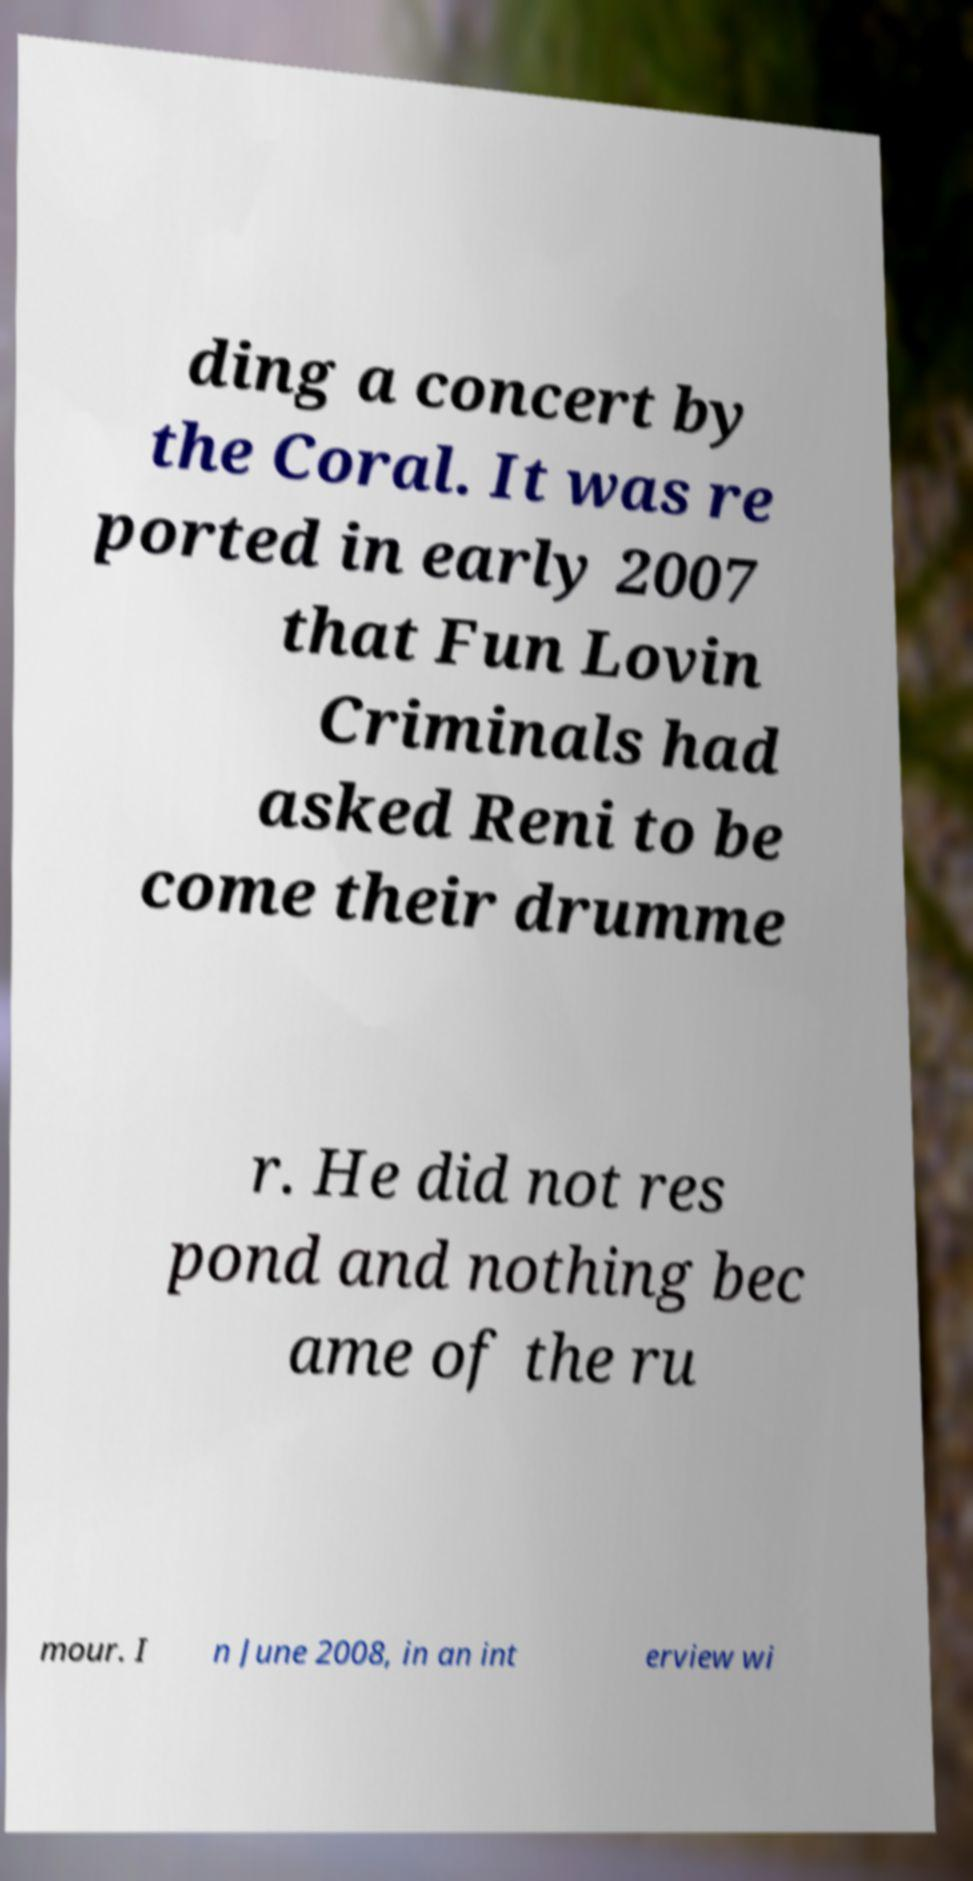Please identify and transcribe the text found in this image. ding a concert by the Coral. It was re ported in early 2007 that Fun Lovin Criminals had asked Reni to be come their drumme r. He did not res pond and nothing bec ame of the ru mour. I n June 2008, in an int erview wi 